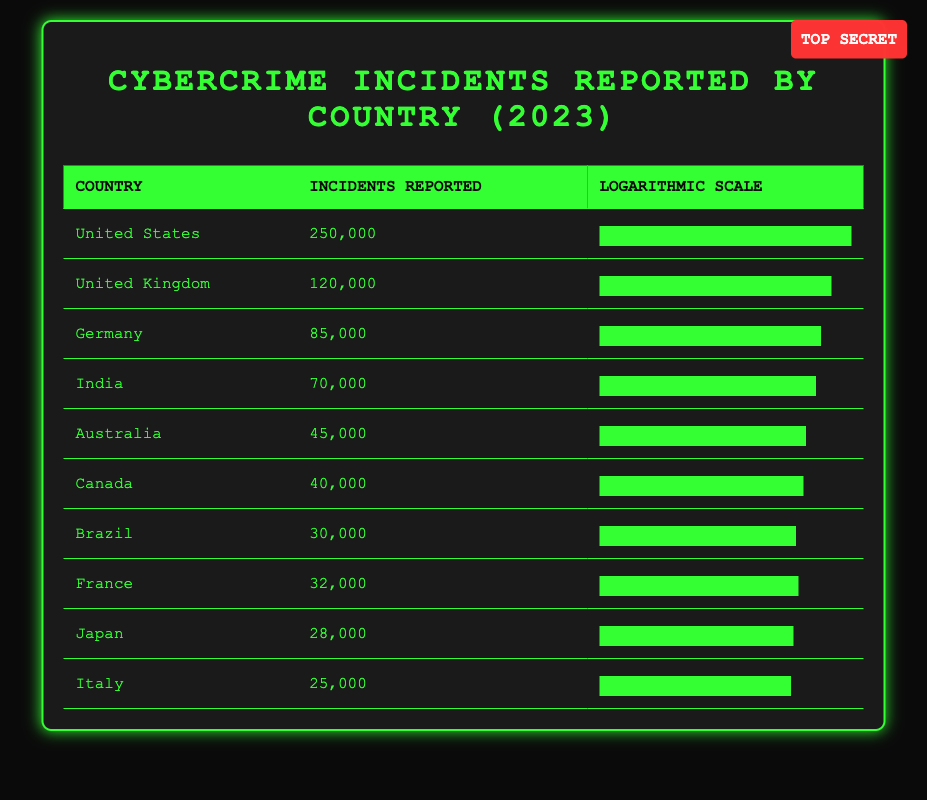What country reported the highest number of cybercrime incidents in 2023? The table shows the 'Incidents Reported' column, and the United States has the highest value at 250,000 incidents.
Answer: United States How many incidents were reported in Germany? The table directly states that Germany reported 85,000 incidents.
Answer: 85,000 Which country had fewer incidents: Canada or Australia? Canada reported 40,000 incidents while Australia reported 45,000. Since 40,000 is less than 45,000, Canada had fewer incidents.
Answer: Canada What is the total number of cybercrime incidents reported by the top three countries? The top three countries are the United States (250,000), the United Kingdom (120,000), and Germany (85,000). Adding these gives 250,000 + 120,000 + 85,000 = 455,000 incidents.
Answer: 455,000 Is the number of incidents reported by France higher than that reported by Brazil? France reported 32,000 incidents, while Brazil reported 30,000 incidents. Since 32,000 is greater than 30,000, the statement is true.
Answer: Yes What is the average number of incidents reported across all countries listed? To find the average, sum up all incidents (250,000 + 120,000 + 85,000 + 70,000 + 45,000 + 40,000 + 30,000 + 32,000 + 28,000 + 25,000 = 650,000). There are 10 countries, so the average is 650,000 / 10 = 65,000.
Answer: 65,000 Which two countries have a combined total of 100,000 incidents? By combining Canada (40,000) and Australia (45,000) we get 40,000 + 45,000 = 85,000, and combining Italy (25,000) with Japan (28,000) gives 25,000 + 28,000 = 53,000. The only countries that combine closest to 100,000 not exceeding it are India (70,000) and Brazil (30,000) totaling 100,000 exactly.
Answer: India and Brazil How many more incidents were reported in the United Kingdom than in Italy? The United Kingdom had 120,000 incidents while Italy had 25,000. Subtracting these gives 120,000 - 25,000 = 95,000.
Answer: 95,000 Which country had the least number of reported incidents, and what was the number? The table shows that Italy had the least number of incidents reported at 25,000.
Answer: Italy, 25,000 